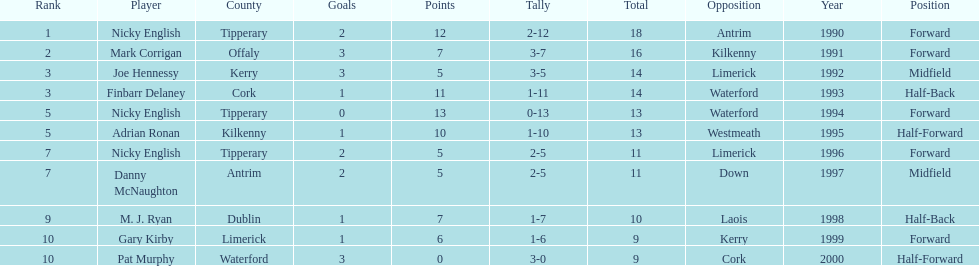How many times was waterford the opposition? 2. 